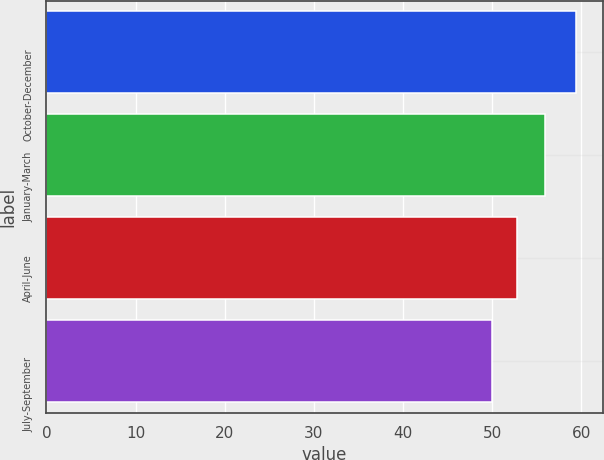Convert chart to OTSL. <chart><loc_0><loc_0><loc_500><loc_500><bar_chart><fcel>October-December<fcel>January-March<fcel>April-June<fcel>July-September<nl><fcel>59.43<fcel>55.91<fcel>52.76<fcel>49.96<nl></chart> 